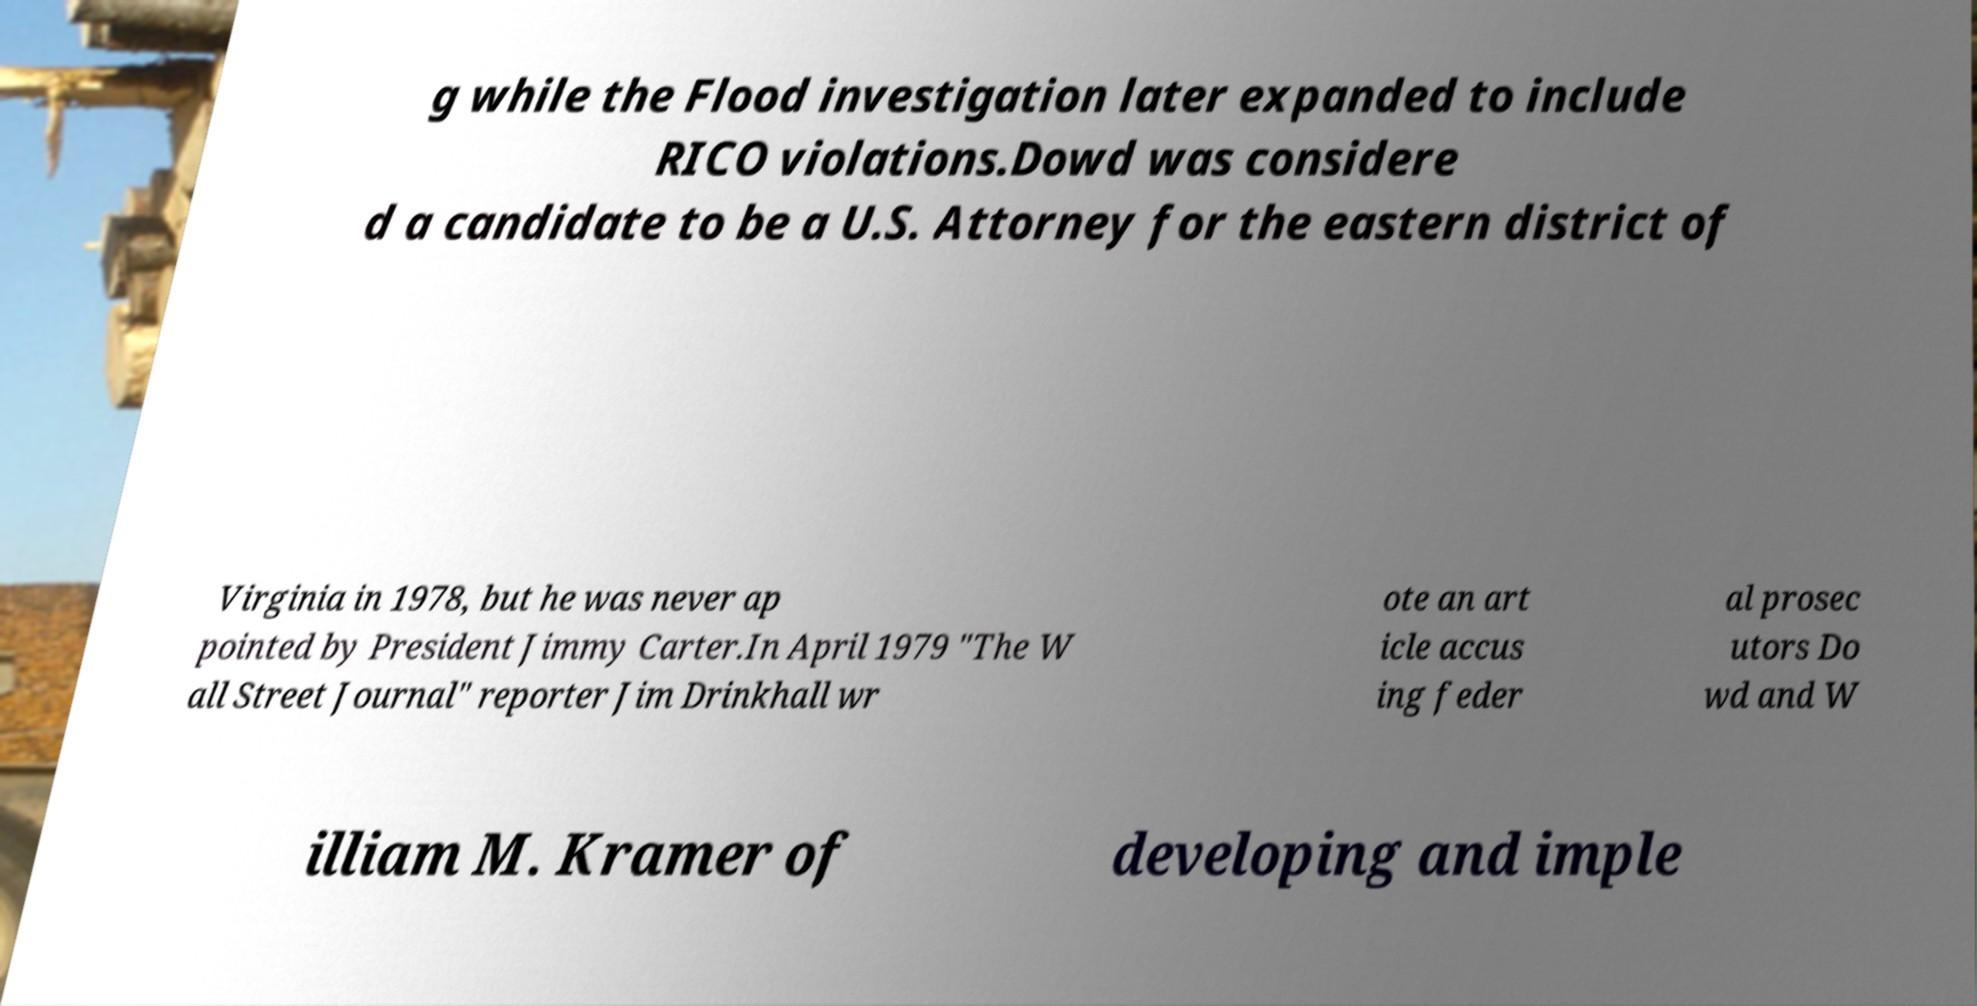There's text embedded in this image that I need extracted. Can you transcribe it verbatim? g while the Flood investigation later expanded to include RICO violations.Dowd was considere d a candidate to be a U.S. Attorney for the eastern district of Virginia in 1978, but he was never ap pointed by President Jimmy Carter.In April 1979 "The W all Street Journal" reporter Jim Drinkhall wr ote an art icle accus ing feder al prosec utors Do wd and W illiam M. Kramer of developing and imple 